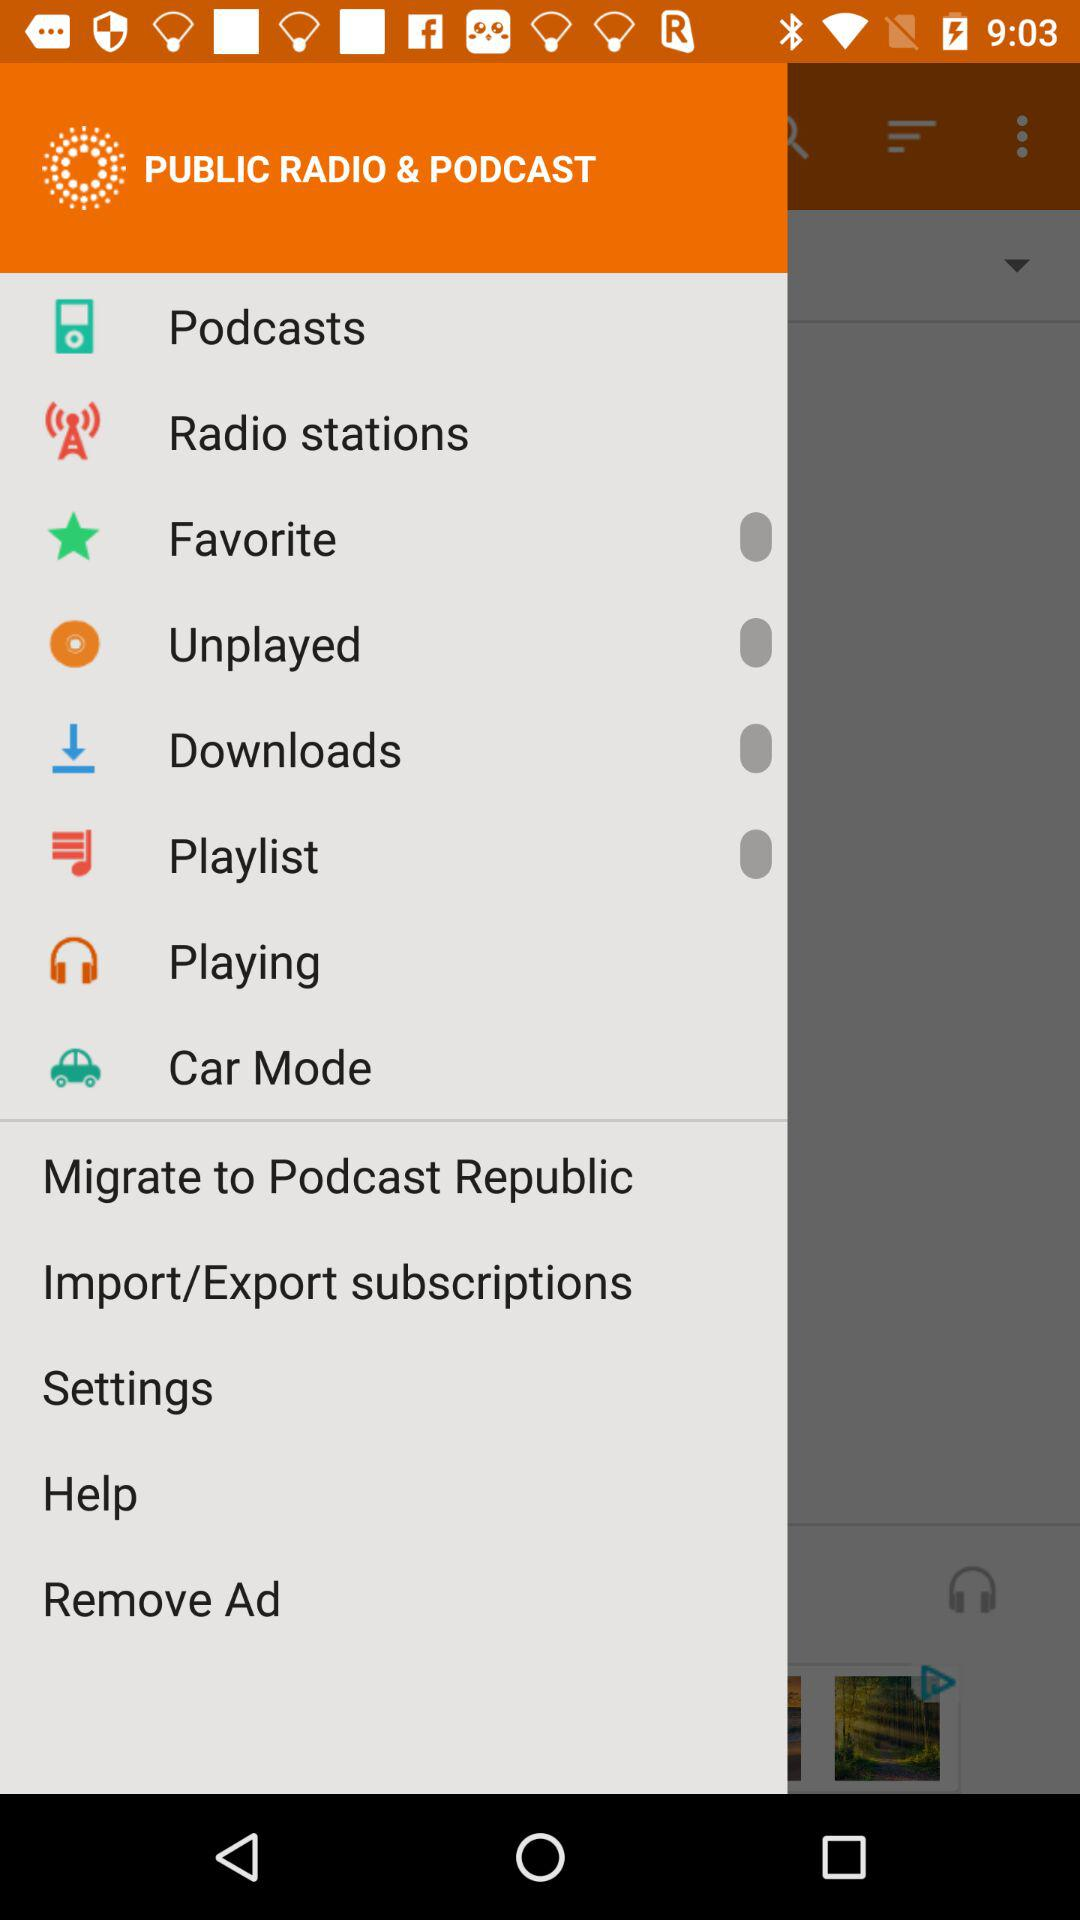Which podcasts are available to stream?
When the provided information is insufficient, respond with <no answer>. <no answer> 